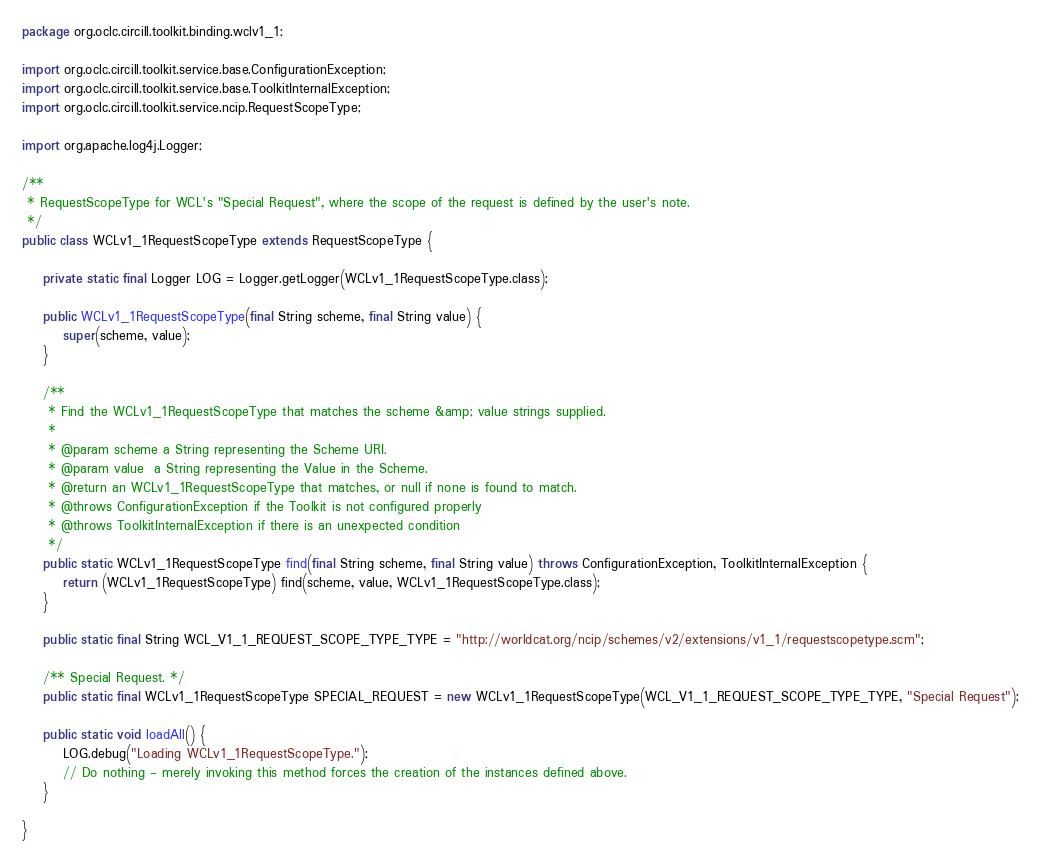Convert code to text. <code><loc_0><loc_0><loc_500><loc_500><_Java_>
package org.oclc.circill.toolkit.binding.wclv1_1;

import org.oclc.circill.toolkit.service.base.ConfigurationException;
import org.oclc.circill.toolkit.service.base.ToolkitInternalException;
import org.oclc.circill.toolkit.service.ncip.RequestScopeType;

import org.apache.log4j.Logger;

/**
 * RequestScopeType for WCL's "Special Request", where the scope of the request is defined by the user's note.
 */
public class WCLv1_1RequestScopeType extends RequestScopeType {

    private static final Logger LOG = Logger.getLogger(WCLv1_1RequestScopeType.class);

    public WCLv1_1RequestScopeType(final String scheme, final String value) {
        super(scheme, value);
    }

    /**
     * Find the WCLv1_1RequestScopeType that matches the scheme &amp; value strings supplied.
     *
     * @param scheme a String representing the Scheme URI.
     * @param value  a String representing the Value in the Scheme.
     * @return an WCLv1_1RequestScopeType that matches, or null if none is found to match.
     * @throws ConfigurationException if the Toolkit is not configured properly
     * @throws ToolkitInternalException if there is an unexpected condition
     */
    public static WCLv1_1RequestScopeType find(final String scheme, final String value) throws ConfigurationException, ToolkitInternalException {
        return (WCLv1_1RequestScopeType) find(scheme, value, WCLv1_1RequestScopeType.class);
    }

    public static final String WCL_V1_1_REQUEST_SCOPE_TYPE_TYPE = "http://worldcat.org/ncip/schemes/v2/extensions/v1_1/requestscopetype.scm";

    /** Special Request. */
    public static final WCLv1_1RequestScopeType SPECIAL_REQUEST = new WCLv1_1RequestScopeType(WCL_V1_1_REQUEST_SCOPE_TYPE_TYPE, "Special Request");

    public static void loadAll() {
        LOG.debug("Loading WCLv1_1RequestScopeType.");
        // Do nothing - merely invoking this method forces the creation of the instances defined above.
    }

}
</code> 